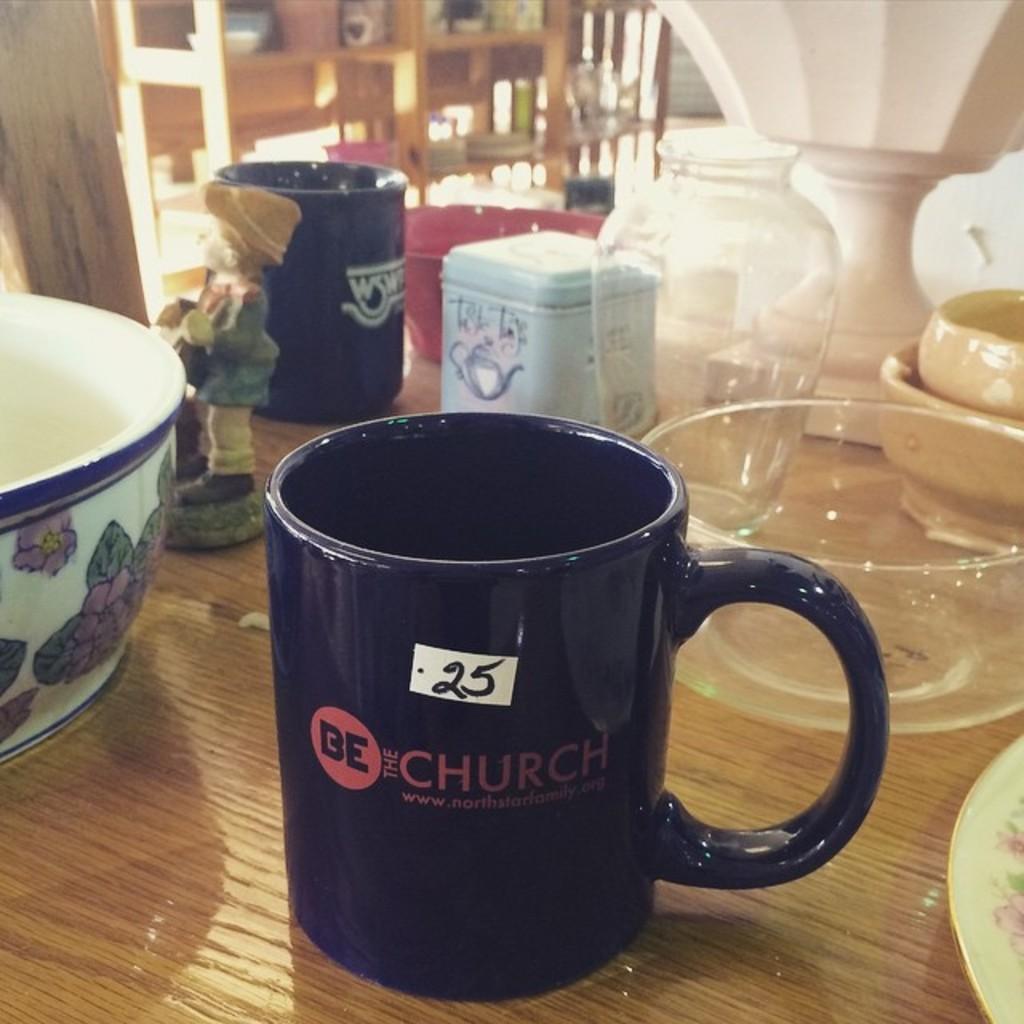Can you describe this image briefly? In this picture we can see a toy, few cups, bowls and other things on the table and we can see blurry background. 